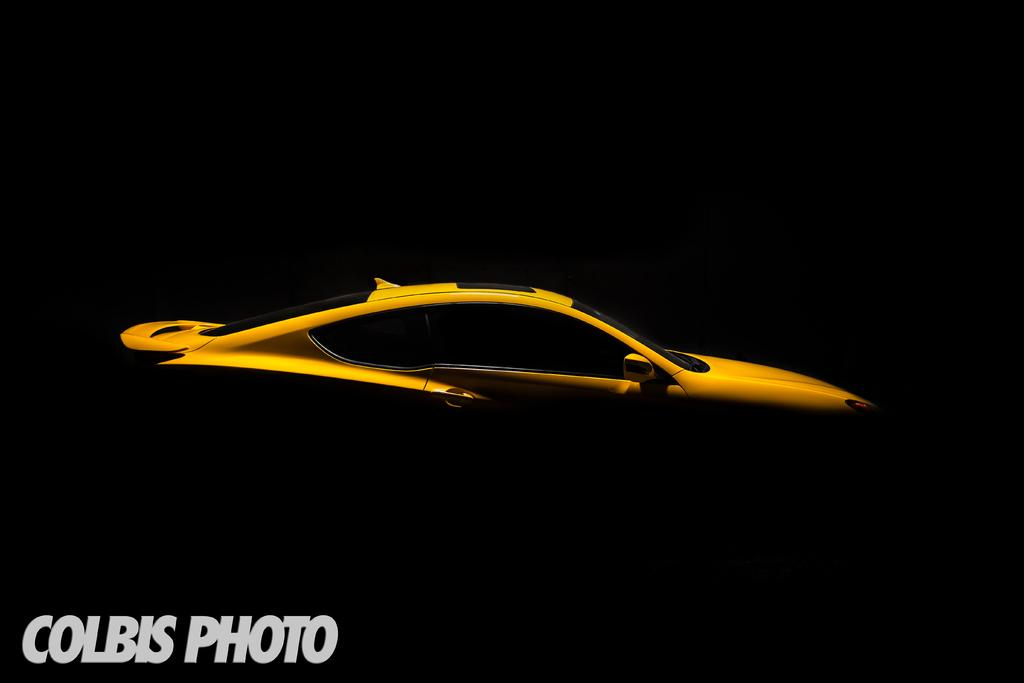What is the main subject of the poster in the image? The poster features a yellow car in the center. Where is the watermark located in the image? The watermark is in the bottom left corner of the image. How would you describe the lighting at the top of the image? The top of the image appears to be dark. Is there a bear climbing a slope in the image? No, there is no bear or slope present in the image. Can you see an arch in the background of the image? No, there is no arch visible in the image. 